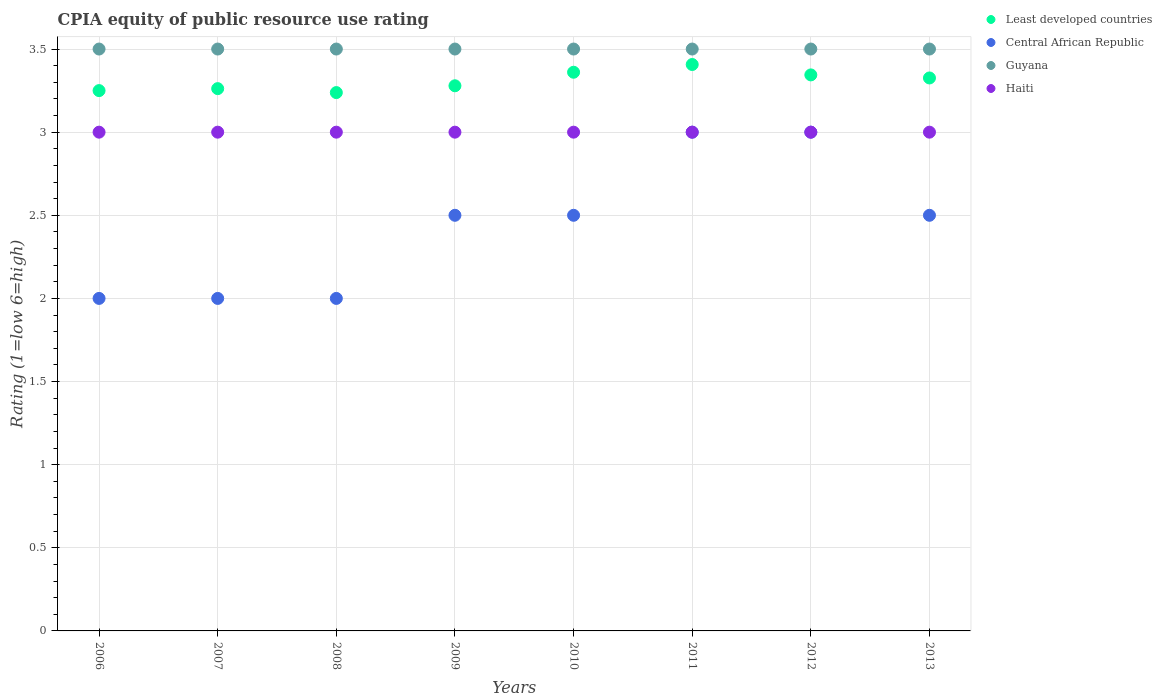Is the number of dotlines equal to the number of legend labels?
Your answer should be compact. Yes. What is the CPIA rating in Least developed countries in 2009?
Ensure brevity in your answer.  3.28. Across all years, what is the maximum CPIA rating in Haiti?
Make the answer very short. 3. In which year was the CPIA rating in Least developed countries maximum?
Offer a very short reply. 2011. What is the total CPIA rating in Haiti in the graph?
Ensure brevity in your answer.  24. What is the difference between the CPIA rating in Central African Republic in 2008 and the CPIA rating in Haiti in 2007?
Your response must be concise. -1. What is the average CPIA rating in Central African Republic per year?
Offer a terse response. 2.44. In the year 2010, what is the difference between the CPIA rating in Least developed countries and CPIA rating in Guyana?
Offer a very short reply. -0.14. In how many years, is the CPIA rating in Least developed countries greater than 0.2?
Offer a very short reply. 8. Is the CPIA rating in Haiti in 2006 less than that in 2013?
Your answer should be compact. No. Is the difference between the CPIA rating in Least developed countries in 2008 and 2012 greater than the difference between the CPIA rating in Guyana in 2008 and 2012?
Offer a terse response. No. What is the difference between the highest and the second highest CPIA rating in Guyana?
Offer a terse response. 0. What is the difference between the highest and the lowest CPIA rating in Least developed countries?
Ensure brevity in your answer.  0.17. Is the sum of the CPIA rating in Least developed countries in 2010 and 2013 greater than the maximum CPIA rating in Haiti across all years?
Your answer should be very brief. Yes. Does the CPIA rating in Central African Republic monotonically increase over the years?
Your answer should be compact. No. Is the CPIA rating in Haiti strictly less than the CPIA rating in Least developed countries over the years?
Offer a terse response. Yes. How many dotlines are there?
Provide a short and direct response. 4. How many years are there in the graph?
Ensure brevity in your answer.  8. Does the graph contain any zero values?
Provide a short and direct response. No. Does the graph contain grids?
Offer a very short reply. Yes. Where does the legend appear in the graph?
Offer a very short reply. Top right. What is the title of the graph?
Offer a very short reply. CPIA equity of public resource use rating. Does "Montenegro" appear as one of the legend labels in the graph?
Keep it short and to the point. No. What is the label or title of the X-axis?
Offer a very short reply. Years. What is the label or title of the Y-axis?
Your response must be concise. Rating (1=low 6=high). What is the Rating (1=low 6=high) in Least developed countries in 2006?
Your answer should be very brief. 3.25. What is the Rating (1=low 6=high) of Haiti in 2006?
Keep it short and to the point. 3. What is the Rating (1=low 6=high) of Least developed countries in 2007?
Your answer should be very brief. 3.26. What is the Rating (1=low 6=high) in Central African Republic in 2007?
Keep it short and to the point. 2. What is the Rating (1=low 6=high) in Guyana in 2007?
Ensure brevity in your answer.  3.5. What is the Rating (1=low 6=high) of Least developed countries in 2008?
Your answer should be very brief. 3.24. What is the Rating (1=low 6=high) of Least developed countries in 2009?
Provide a succinct answer. 3.28. What is the Rating (1=low 6=high) of Central African Republic in 2009?
Give a very brief answer. 2.5. What is the Rating (1=low 6=high) of Least developed countries in 2010?
Make the answer very short. 3.36. What is the Rating (1=low 6=high) in Central African Republic in 2010?
Give a very brief answer. 2.5. What is the Rating (1=low 6=high) in Guyana in 2010?
Provide a short and direct response. 3.5. What is the Rating (1=low 6=high) in Haiti in 2010?
Offer a very short reply. 3. What is the Rating (1=low 6=high) in Least developed countries in 2011?
Make the answer very short. 3.41. What is the Rating (1=low 6=high) in Least developed countries in 2012?
Provide a succinct answer. 3.34. What is the Rating (1=low 6=high) of Central African Republic in 2012?
Give a very brief answer. 3. What is the Rating (1=low 6=high) of Guyana in 2012?
Offer a terse response. 3.5. What is the Rating (1=low 6=high) in Haiti in 2012?
Your answer should be very brief. 3. What is the Rating (1=low 6=high) in Least developed countries in 2013?
Offer a very short reply. 3.33. What is the Rating (1=low 6=high) in Central African Republic in 2013?
Provide a succinct answer. 2.5. What is the Rating (1=low 6=high) in Guyana in 2013?
Offer a terse response. 3.5. Across all years, what is the maximum Rating (1=low 6=high) in Least developed countries?
Your answer should be very brief. 3.41. Across all years, what is the maximum Rating (1=low 6=high) in Central African Republic?
Give a very brief answer. 3. Across all years, what is the maximum Rating (1=low 6=high) in Guyana?
Offer a terse response. 3.5. Across all years, what is the maximum Rating (1=low 6=high) of Haiti?
Provide a succinct answer. 3. Across all years, what is the minimum Rating (1=low 6=high) of Least developed countries?
Make the answer very short. 3.24. Across all years, what is the minimum Rating (1=low 6=high) of Guyana?
Your answer should be compact. 3.5. Across all years, what is the minimum Rating (1=low 6=high) of Haiti?
Make the answer very short. 3. What is the total Rating (1=low 6=high) in Least developed countries in the graph?
Offer a terse response. 26.47. What is the total Rating (1=low 6=high) of Guyana in the graph?
Your response must be concise. 28. What is the difference between the Rating (1=low 6=high) in Least developed countries in 2006 and that in 2007?
Provide a succinct answer. -0.01. What is the difference between the Rating (1=low 6=high) of Guyana in 2006 and that in 2007?
Provide a short and direct response. 0. What is the difference between the Rating (1=low 6=high) of Least developed countries in 2006 and that in 2008?
Ensure brevity in your answer.  0.01. What is the difference between the Rating (1=low 6=high) of Central African Republic in 2006 and that in 2008?
Ensure brevity in your answer.  0. What is the difference between the Rating (1=low 6=high) in Guyana in 2006 and that in 2008?
Your response must be concise. 0. What is the difference between the Rating (1=low 6=high) of Least developed countries in 2006 and that in 2009?
Make the answer very short. -0.03. What is the difference between the Rating (1=low 6=high) in Central African Republic in 2006 and that in 2009?
Provide a succinct answer. -0.5. What is the difference between the Rating (1=low 6=high) in Least developed countries in 2006 and that in 2010?
Keep it short and to the point. -0.11. What is the difference between the Rating (1=low 6=high) of Central African Republic in 2006 and that in 2010?
Keep it short and to the point. -0.5. What is the difference between the Rating (1=low 6=high) in Guyana in 2006 and that in 2010?
Make the answer very short. 0. What is the difference between the Rating (1=low 6=high) in Least developed countries in 2006 and that in 2011?
Your answer should be compact. -0.16. What is the difference between the Rating (1=low 6=high) of Central African Republic in 2006 and that in 2011?
Your answer should be very brief. -1. What is the difference between the Rating (1=low 6=high) of Haiti in 2006 and that in 2011?
Provide a short and direct response. 0. What is the difference between the Rating (1=low 6=high) of Least developed countries in 2006 and that in 2012?
Offer a terse response. -0.09. What is the difference between the Rating (1=low 6=high) in Central African Republic in 2006 and that in 2012?
Your answer should be compact. -1. What is the difference between the Rating (1=low 6=high) of Least developed countries in 2006 and that in 2013?
Give a very brief answer. -0.08. What is the difference between the Rating (1=low 6=high) in Central African Republic in 2006 and that in 2013?
Offer a terse response. -0.5. What is the difference between the Rating (1=low 6=high) of Haiti in 2006 and that in 2013?
Your response must be concise. 0. What is the difference between the Rating (1=low 6=high) in Least developed countries in 2007 and that in 2008?
Your response must be concise. 0.02. What is the difference between the Rating (1=low 6=high) of Central African Republic in 2007 and that in 2008?
Provide a short and direct response. 0. What is the difference between the Rating (1=low 6=high) in Guyana in 2007 and that in 2008?
Provide a succinct answer. 0. What is the difference between the Rating (1=low 6=high) in Haiti in 2007 and that in 2008?
Keep it short and to the point. 0. What is the difference between the Rating (1=low 6=high) of Least developed countries in 2007 and that in 2009?
Offer a very short reply. -0.02. What is the difference between the Rating (1=low 6=high) of Least developed countries in 2007 and that in 2010?
Your answer should be compact. -0.1. What is the difference between the Rating (1=low 6=high) of Least developed countries in 2007 and that in 2011?
Keep it short and to the point. -0.15. What is the difference between the Rating (1=low 6=high) in Central African Republic in 2007 and that in 2011?
Make the answer very short. -1. What is the difference between the Rating (1=low 6=high) in Guyana in 2007 and that in 2011?
Provide a succinct answer. 0. What is the difference between the Rating (1=low 6=high) of Least developed countries in 2007 and that in 2012?
Offer a very short reply. -0.08. What is the difference between the Rating (1=low 6=high) of Central African Republic in 2007 and that in 2012?
Provide a short and direct response. -1. What is the difference between the Rating (1=low 6=high) in Guyana in 2007 and that in 2012?
Give a very brief answer. 0. What is the difference between the Rating (1=low 6=high) of Least developed countries in 2007 and that in 2013?
Your response must be concise. -0.06. What is the difference between the Rating (1=low 6=high) in Central African Republic in 2007 and that in 2013?
Keep it short and to the point. -0.5. What is the difference between the Rating (1=low 6=high) in Guyana in 2007 and that in 2013?
Give a very brief answer. 0. What is the difference between the Rating (1=low 6=high) in Least developed countries in 2008 and that in 2009?
Ensure brevity in your answer.  -0.04. What is the difference between the Rating (1=low 6=high) of Central African Republic in 2008 and that in 2009?
Offer a terse response. -0.5. What is the difference between the Rating (1=low 6=high) of Least developed countries in 2008 and that in 2010?
Ensure brevity in your answer.  -0.12. What is the difference between the Rating (1=low 6=high) of Central African Republic in 2008 and that in 2010?
Your response must be concise. -0.5. What is the difference between the Rating (1=low 6=high) of Guyana in 2008 and that in 2010?
Make the answer very short. 0. What is the difference between the Rating (1=low 6=high) in Haiti in 2008 and that in 2010?
Your answer should be very brief. 0. What is the difference between the Rating (1=low 6=high) in Least developed countries in 2008 and that in 2011?
Keep it short and to the point. -0.17. What is the difference between the Rating (1=low 6=high) of Central African Republic in 2008 and that in 2011?
Provide a succinct answer. -1. What is the difference between the Rating (1=low 6=high) of Haiti in 2008 and that in 2011?
Your answer should be compact. 0. What is the difference between the Rating (1=low 6=high) in Least developed countries in 2008 and that in 2012?
Give a very brief answer. -0.11. What is the difference between the Rating (1=low 6=high) of Guyana in 2008 and that in 2012?
Keep it short and to the point. 0. What is the difference between the Rating (1=low 6=high) of Haiti in 2008 and that in 2012?
Your answer should be compact. 0. What is the difference between the Rating (1=low 6=high) in Least developed countries in 2008 and that in 2013?
Provide a short and direct response. -0.09. What is the difference between the Rating (1=low 6=high) of Central African Republic in 2008 and that in 2013?
Offer a very short reply. -0.5. What is the difference between the Rating (1=low 6=high) in Guyana in 2008 and that in 2013?
Your response must be concise. 0. What is the difference between the Rating (1=low 6=high) in Haiti in 2008 and that in 2013?
Provide a succinct answer. 0. What is the difference between the Rating (1=low 6=high) in Least developed countries in 2009 and that in 2010?
Ensure brevity in your answer.  -0.08. What is the difference between the Rating (1=low 6=high) of Guyana in 2009 and that in 2010?
Your response must be concise. 0. What is the difference between the Rating (1=low 6=high) of Haiti in 2009 and that in 2010?
Give a very brief answer. 0. What is the difference between the Rating (1=low 6=high) in Least developed countries in 2009 and that in 2011?
Give a very brief answer. -0.13. What is the difference between the Rating (1=low 6=high) in Central African Republic in 2009 and that in 2011?
Offer a terse response. -0.5. What is the difference between the Rating (1=low 6=high) in Haiti in 2009 and that in 2011?
Ensure brevity in your answer.  0. What is the difference between the Rating (1=low 6=high) in Least developed countries in 2009 and that in 2012?
Give a very brief answer. -0.07. What is the difference between the Rating (1=low 6=high) in Central African Republic in 2009 and that in 2012?
Keep it short and to the point. -0.5. What is the difference between the Rating (1=low 6=high) in Guyana in 2009 and that in 2012?
Your answer should be very brief. 0. What is the difference between the Rating (1=low 6=high) of Haiti in 2009 and that in 2012?
Offer a terse response. 0. What is the difference between the Rating (1=low 6=high) of Least developed countries in 2009 and that in 2013?
Your response must be concise. -0.05. What is the difference between the Rating (1=low 6=high) of Least developed countries in 2010 and that in 2011?
Provide a short and direct response. -0.05. What is the difference between the Rating (1=low 6=high) of Central African Republic in 2010 and that in 2011?
Your response must be concise. -0.5. What is the difference between the Rating (1=low 6=high) in Least developed countries in 2010 and that in 2012?
Your response must be concise. 0.02. What is the difference between the Rating (1=low 6=high) in Central African Republic in 2010 and that in 2012?
Your answer should be compact. -0.5. What is the difference between the Rating (1=low 6=high) of Haiti in 2010 and that in 2012?
Your answer should be compact. 0. What is the difference between the Rating (1=low 6=high) in Least developed countries in 2010 and that in 2013?
Your answer should be compact. 0.03. What is the difference between the Rating (1=low 6=high) of Central African Republic in 2010 and that in 2013?
Your response must be concise. 0. What is the difference between the Rating (1=low 6=high) of Haiti in 2010 and that in 2013?
Make the answer very short. 0. What is the difference between the Rating (1=low 6=high) in Least developed countries in 2011 and that in 2012?
Provide a succinct answer. 0.06. What is the difference between the Rating (1=low 6=high) in Haiti in 2011 and that in 2012?
Provide a succinct answer. 0. What is the difference between the Rating (1=low 6=high) of Least developed countries in 2011 and that in 2013?
Your response must be concise. 0.08. What is the difference between the Rating (1=low 6=high) of Guyana in 2011 and that in 2013?
Give a very brief answer. 0. What is the difference between the Rating (1=low 6=high) in Least developed countries in 2012 and that in 2013?
Offer a terse response. 0.02. What is the difference between the Rating (1=low 6=high) in Least developed countries in 2006 and the Rating (1=low 6=high) in Central African Republic in 2007?
Make the answer very short. 1.25. What is the difference between the Rating (1=low 6=high) of Least developed countries in 2006 and the Rating (1=low 6=high) of Guyana in 2007?
Ensure brevity in your answer.  -0.25. What is the difference between the Rating (1=low 6=high) of Least developed countries in 2006 and the Rating (1=low 6=high) of Haiti in 2007?
Make the answer very short. 0.25. What is the difference between the Rating (1=low 6=high) in Central African Republic in 2006 and the Rating (1=low 6=high) in Guyana in 2007?
Provide a succinct answer. -1.5. What is the difference between the Rating (1=low 6=high) in Central African Republic in 2006 and the Rating (1=low 6=high) in Haiti in 2007?
Your response must be concise. -1. What is the difference between the Rating (1=low 6=high) in Least developed countries in 2006 and the Rating (1=low 6=high) in Central African Republic in 2008?
Make the answer very short. 1.25. What is the difference between the Rating (1=low 6=high) of Central African Republic in 2006 and the Rating (1=low 6=high) of Guyana in 2008?
Make the answer very short. -1.5. What is the difference between the Rating (1=low 6=high) of Guyana in 2006 and the Rating (1=low 6=high) of Haiti in 2008?
Your answer should be compact. 0.5. What is the difference between the Rating (1=low 6=high) of Least developed countries in 2006 and the Rating (1=low 6=high) of Guyana in 2009?
Your answer should be compact. -0.25. What is the difference between the Rating (1=low 6=high) in Least developed countries in 2006 and the Rating (1=low 6=high) in Haiti in 2009?
Ensure brevity in your answer.  0.25. What is the difference between the Rating (1=low 6=high) of Central African Republic in 2006 and the Rating (1=low 6=high) of Haiti in 2009?
Give a very brief answer. -1. What is the difference between the Rating (1=low 6=high) of Least developed countries in 2006 and the Rating (1=low 6=high) of Central African Republic in 2010?
Provide a short and direct response. 0.75. What is the difference between the Rating (1=low 6=high) of Least developed countries in 2006 and the Rating (1=low 6=high) of Guyana in 2010?
Offer a terse response. -0.25. What is the difference between the Rating (1=low 6=high) of Least developed countries in 2006 and the Rating (1=low 6=high) of Haiti in 2010?
Provide a succinct answer. 0.25. What is the difference between the Rating (1=low 6=high) of Central African Republic in 2006 and the Rating (1=low 6=high) of Guyana in 2010?
Your answer should be very brief. -1.5. What is the difference between the Rating (1=low 6=high) of Guyana in 2006 and the Rating (1=low 6=high) of Haiti in 2010?
Keep it short and to the point. 0.5. What is the difference between the Rating (1=low 6=high) in Least developed countries in 2006 and the Rating (1=low 6=high) in Guyana in 2011?
Give a very brief answer. -0.25. What is the difference between the Rating (1=low 6=high) in Central African Republic in 2006 and the Rating (1=low 6=high) in Haiti in 2011?
Give a very brief answer. -1. What is the difference between the Rating (1=low 6=high) of Least developed countries in 2006 and the Rating (1=low 6=high) of Central African Republic in 2012?
Your answer should be compact. 0.25. What is the difference between the Rating (1=low 6=high) in Central African Republic in 2006 and the Rating (1=low 6=high) in Guyana in 2012?
Provide a short and direct response. -1.5. What is the difference between the Rating (1=low 6=high) in Central African Republic in 2006 and the Rating (1=low 6=high) in Haiti in 2012?
Ensure brevity in your answer.  -1. What is the difference between the Rating (1=low 6=high) in Least developed countries in 2006 and the Rating (1=low 6=high) in Central African Republic in 2013?
Provide a succinct answer. 0.75. What is the difference between the Rating (1=low 6=high) of Least developed countries in 2006 and the Rating (1=low 6=high) of Guyana in 2013?
Offer a very short reply. -0.25. What is the difference between the Rating (1=low 6=high) of Least developed countries in 2006 and the Rating (1=low 6=high) of Haiti in 2013?
Make the answer very short. 0.25. What is the difference between the Rating (1=low 6=high) of Least developed countries in 2007 and the Rating (1=low 6=high) of Central African Republic in 2008?
Provide a succinct answer. 1.26. What is the difference between the Rating (1=low 6=high) of Least developed countries in 2007 and the Rating (1=low 6=high) of Guyana in 2008?
Your response must be concise. -0.24. What is the difference between the Rating (1=low 6=high) in Least developed countries in 2007 and the Rating (1=low 6=high) in Haiti in 2008?
Ensure brevity in your answer.  0.26. What is the difference between the Rating (1=low 6=high) of Central African Republic in 2007 and the Rating (1=low 6=high) of Haiti in 2008?
Your answer should be compact. -1. What is the difference between the Rating (1=low 6=high) in Least developed countries in 2007 and the Rating (1=low 6=high) in Central African Republic in 2009?
Your response must be concise. 0.76. What is the difference between the Rating (1=low 6=high) in Least developed countries in 2007 and the Rating (1=low 6=high) in Guyana in 2009?
Ensure brevity in your answer.  -0.24. What is the difference between the Rating (1=low 6=high) of Least developed countries in 2007 and the Rating (1=low 6=high) of Haiti in 2009?
Offer a very short reply. 0.26. What is the difference between the Rating (1=low 6=high) of Guyana in 2007 and the Rating (1=low 6=high) of Haiti in 2009?
Ensure brevity in your answer.  0.5. What is the difference between the Rating (1=low 6=high) of Least developed countries in 2007 and the Rating (1=low 6=high) of Central African Republic in 2010?
Your response must be concise. 0.76. What is the difference between the Rating (1=low 6=high) of Least developed countries in 2007 and the Rating (1=low 6=high) of Guyana in 2010?
Your answer should be very brief. -0.24. What is the difference between the Rating (1=low 6=high) of Least developed countries in 2007 and the Rating (1=low 6=high) of Haiti in 2010?
Your answer should be compact. 0.26. What is the difference between the Rating (1=low 6=high) of Central African Republic in 2007 and the Rating (1=low 6=high) of Guyana in 2010?
Offer a terse response. -1.5. What is the difference between the Rating (1=low 6=high) of Guyana in 2007 and the Rating (1=low 6=high) of Haiti in 2010?
Provide a succinct answer. 0.5. What is the difference between the Rating (1=low 6=high) of Least developed countries in 2007 and the Rating (1=low 6=high) of Central African Republic in 2011?
Keep it short and to the point. 0.26. What is the difference between the Rating (1=low 6=high) of Least developed countries in 2007 and the Rating (1=low 6=high) of Guyana in 2011?
Ensure brevity in your answer.  -0.24. What is the difference between the Rating (1=low 6=high) in Least developed countries in 2007 and the Rating (1=low 6=high) in Haiti in 2011?
Make the answer very short. 0.26. What is the difference between the Rating (1=low 6=high) in Central African Republic in 2007 and the Rating (1=low 6=high) in Guyana in 2011?
Your answer should be very brief. -1.5. What is the difference between the Rating (1=low 6=high) of Guyana in 2007 and the Rating (1=low 6=high) of Haiti in 2011?
Your answer should be compact. 0.5. What is the difference between the Rating (1=low 6=high) in Least developed countries in 2007 and the Rating (1=low 6=high) in Central African Republic in 2012?
Offer a terse response. 0.26. What is the difference between the Rating (1=low 6=high) in Least developed countries in 2007 and the Rating (1=low 6=high) in Guyana in 2012?
Provide a succinct answer. -0.24. What is the difference between the Rating (1=low 6=high) of Least developed countries in 2007 and the Rating (1=low 6=high) of Haiti in 2012?
Give a very brief answer. 0.26. What is the difference between the Rating (1=low 6=high) in Central African Republic in 2007 and the Rating (1=low 6=high) in Guyana in 2012?
Provide a succinct answer. -1.5. What is the difference between the Rating (1=low 6=high) of Central African Republic in 2007 and the Rating (1=low 6=high) of Haiti in 2012?
Keep it short and to the point. -1. What is the difference between the Rating (1=low 6=high) of Least developed countries in 2007 and the Rating (1=low 6=high) of Central African Republic in 2013?
Ensure brevity in your answer.  0.76. What is the difference between the Rating (1=low 6=high) of Least developed countries in 2007 and the Rating (1=low 6=high) of Guyana in 2013?
Provide a short and direct response. -0.24. What is the difference between the Rating (1=low 6=high) of Least developed countries in 2007 and the Rating (1=low 6=high) of Haiti in 2013?
Your answer should be very brief. 0.26. What is the difference between the Rating (1=low 6=high) in Central African Republic in 2007 and the Rating (1=low 6=high) in Guyana in 2013?
Your response must be concise. -1.5. What is the difference between the Rating (1=low 6=high) in Guyana in 2007 and the Rating (1=low 6=high) in Haiti in 2013?
Your answer should be compact. 0.5. What is the difference between the Rating (1=low 6=high) in Least developed countries in 2008 and the Rating (1=low 6=high) in Central African Republic in 2009?
Your response must be concise. 0.74. What is the difference between the Rating (1=low 6=high) of Least developed countries in 2008 and the Rating (1=low 6=high) of Guyana in 2009?
Your response must be concise. -0.26. What is the difference between the Rating (1=low 6=high) of Least developed countries in 2008 and the Rating (1=low 6=high) of Haiti in 2009?
Ensure brevity in your answer.  0.24. What is the difference between the Rating (1=low 6=high) of Central African Republic in 2008 and the Rating (1=low 6=high) of Guyana in 2009?
Your answer should be compact. -1.5. What is the difference between the Rating (1=low 6=high) of Least developed countries in 2008 and the Rating (1=low 6=high) of Central African Republic in 2010?
Ensure brevity in your answer.  0.74. What is the difference between the Rating (1=low 6=high) of Least developed countries in 2008 and the Rating (1=low 6=high) of Guyana in 2010?
Your answer should be compact. -0.26. What is the difference between the Rating (1=low 6=high) in Least developed countries in 2008 and the Rating (1=low 6=high) in Haiti in 2010?
Provide a short and direct response. 0.24. What is the difference between the Rating (1=low 6=high) in Central African Republic in 2008 and the Rating (1=low 6=high) in Guyana in 2010?
Keep it short and to the point. -1.5. What is the difference between the Rating (1=low 6=high) in Central African Republic in 2008 and the Rating (1=low 6=high) in Haiti in 2010?
Provide a succinct answer. -1. What is the difference between the Rating (1=low 6=high) of Least developed countries in 2008 and the Rating (1=low 6=high) of Central African Republic in 2011?
Give a very brief answer. 0.24. What is the difference between the Rating (1=low 6=high) of Least developed countries in 2008 and the Rating (1=low 6=high) of Guyana in 2011?
Offer a terse response. -0.26. What is the difference between the Rating (1=low 6=high) in Least developed countries in 2008 and the Rating (1=low 6=high) in Haiti in 2011?
Provide a succinct answer. 0.24. What is the difference between the Rating (1=low 6=high) in Central African Republic in 2008 and the Rating (1=low 6=high) in Haiti in 2011?
Offer a terse response. -1. What is the difference between the Rating (1=low 6=high) in Least developed countries in 2008 and the Rating (1=low 6=high) in Central African Republic in 2012?
Offer a very short reply. 0.24. What is the difference between the Rating (1=low 6=high) of Least developed countries in 2008 and the Rating (1=low 6=high) of Guyana in 2012?
Provide a short and direct response. -0.26. What is the difference between the Rating (1=low 6=high) of Least developed countries in 2008 and the Rating (1=low 6=high) of Haiti in 2012?
Your answer should be very brief. 0.24. What is the difference between the Rating (1=low 6=high) in Central African Republic in 2008 and the Rating (1=low 6=high) in Guyana in 2012?
Ensure brevity in your answer.  -1.5. What is the difference between the Rating (1=low 6=high) in Guyana in 2008 and the Rating (1=low 6=high) in Haiti in 2012?
Give a very brief answer. 0.5. What is the difference between the Rating (1=low 6=high) in Least developed countries in 2008 and the Rating (1=low 6=high) in Central African Republic in 2013?
Give a very brief answer. 0.74. What is the difference between the Rating (1=low 6=high) in Least developed countries in 2008 and the Rating (1=low 6=high) in Guyana in 2013?
Offer a terse response. -0.26. What is the difference between the Rating (1=low 6=high) in Least developed countries in 2008 and the Rating (1=low 6=high) in Haiti in 2013?
Your answer should be compact. 0.24. What is the difference between the Rating (1=low 6=high) of Central African Republic in 2008 and the Rating (1=low 6=high) of Guyana in 2013?
Ensure brevity in your answer.  -1.5. What is the difference between the Rating (1=low 6=high) in Least developed countries in 2009 and the Rating (1=low 6=high) in Central African Republic in 2010?
Ensure brevity in your answer.  0.78. What is the difference between the Rating (1=low 6=high) in Least developed countries in 2009 and the Rating (1=low 6=high) in Guyana in 2010?
Your answer should be very brief. -0.22. What is the difference between the Rating (1=low 6=high) of Least developed countries in 2009 and the Rating (1=low 6=high) of Haiti in 2010?
Keep it short and to the point. 0.28. What is the difference between the Rating (1=low 6=high) of Central African Republic in 2009 and the Rating (1=low 6=high) of Guyana in 2010?
Make the answer very short. -1. What is the difference between the Rating (1=low 6=high) in Central African Republic in 2009 and the Rating (1=low 6=high) in Haiti in 2010?
Keep it short and to the point. -0.5. What is the difference between the Rating (1=low 6=high) of Least developed countries in 2009 and the Rating (1=low 6=high) of Central African Republic in 2011?
Keep it short and to the point. 0.28. What is the difference between the Rating (1=low 6=high) of Least developed countries in 2009 and the Rating (1=low 6=high) of Guyana in 2011?
Your answer should be compact. -0.22. What is the difference between the Rating (1=low 6=high) in Least developed countries in 2009 and the Rating (1=low 6=high) in Haiti in 2011?
Give a very brief answer. 0.28. What is the difference between the Rating (1=low 6=high) in Central African Republic in 2009 and the Rating (1=low 6=high) in Guyana in 2011?
Offer a very short reply. -1. What is the difference between the Rating (1=low 6=high) of Central African Republic in 2009 and the Rating (1=low 6=high) of Haiti in 2011?
Your answer should be compact. -0.5. What is the difference between the Rating (1=low 6=high) of Guyana in 2009 and the Rating (1=low 6=high) of Haiti in 2011?
Offer a very short reply. 0.5. What is the difference between the Rating (1=low 6=high) in Least developed countries in 2009 and the Rating (1=low 6=high) in Central African Republic in 2012?
Make the answer very short. 0.28. What is the difference between the Rating (1=low 6=high) in Least developed countries in 2009 and the Rating (1=low 6=high) in Guyana in 2012?
Offer a very short reply. -0.22. What is the difference between the Rating (1=low 6=high) in Least developed countries in 2009 and the Rating (1=low 6=high) in Haiti in 2012?
Your answer should be very brief. 0.28. What is the difference between the Rating (1=low 6=high) in Central African Republic in 2009 and the Rating (1=low 6=high) in Haiti in 2012?
Ensure brevity in your answer.  -0.5. What is the difference between the Rating (1=low 6=high) in Least developed countries in 2009 and the Rating (1=low 6=high) in Central African Republic in 2013?
Give a very brief answer. 0.78. What is the difference between the Rating (1=low 6=high) in Least developed countries in 2009 and the Rating (1=low 6=high) in Guyana in 2013?
Your response must be concise. -0.22. What is the difference between the Rating (1=low 6=high) of Least developed countries in 2009 and the Rating (1=low 6=high) of Haiti in 2013?
Offer a very short reply. 0.28. What is the difference between the Rating (1=low 6=high) of Guyana in 2009 and the Rating (1=low 6=high) of Haiti in 2013?
Your answer should be very brief. 0.5. What is the difference between the Rating (1=low 6=high) in Least developed countries in 2010 and the Rating (1=low 6=high) in Central African Republic in 2011?
Give a very brief answer. 0.36. What is the difference between the Rating (1=low 6=high) of Least developed countries in 2010 and the Rating (1=low 6=high) of Guyana in 2011?
Ensure brevity in your answer.  -0.14. What is the difference between the Rating (1=low 6=high) in Least developed countries in 2010 and the Rating (1=low 6=high) in Haiti in 2011?
Offer a terse response. 0.36. What is the difference between the Rating (1=low 6=high) of Central African Republic in 2010 and the Rating (1=low 6=high) of Haiti in 2011?
Offer a terse response. -0.5. What is the difference between the Rating (1=low 6=high) in Guyana in 2010 and the Rating (1=low 6=high) in Haiti in 2011?
Keep it short and to the point. 0.5. What is the difference between the Rating (1=low 6=high) of Least developed countries in 2010 and the Rating (1=low 6=high) of Central African Republic in 2012?
Provide a succinct answer. 0.36. What is the difference between the Rating (1=low 6=high) in Least developed countries in 2010 and the Rating (1=low 6=high) in Guyana in 2012?
Your answer should be compact. -0.14. What is the difference between the Rating (1=low 6=high) in Least developed countries in 2010 and the Rating (1=low 6=high) in Haiti in 2012?
Your answer should be compact. 0.36. What is the difference between the Rating (1=low 6=high) in Central African Republic in 2010 and the Rating (1=low 6=high) in Guyana in 2012?
Your response must be concise. -1. What is the difference between the Rating (1=low 6=high) in Central African Republic in 2010 and the Rating (1=low 6=high) in Haiti in 2012?
Provide a succinct answer. -0.5. What is the difference between the Rating (1=low 6=high) in Guyana in 2010 and the Rating (1=low 6=high) in Haiti in 2012?
Your answer should be compact. 0.5. What is the difference between the Rating (1=low 6=high) in Least developed countries in 2010 and the Rating (1=low 6=high) in Central African Republic in 2013?
Keep it short and to the point. 0.86. What is the difference between the Rating (1=low 6=high) of Least developed countries in 2010 and the Rating (1=low 6=high) of Guyana in 2013?
Your answer should be compact. -0.14. What is the difference between the Rating (1=low 6=high) in Least developed countries in 2010 and the Rating (1=low 6=high) in Haiti in 2013?
Give a very brief answer. 0.36. What is the difference between the Rating (1=low 6=high) in Central African Republic in 2010 and the Rating (1=low 6=high) in Guyana in 2013?
Provide a succinct answer. -1. What is the difference between the Rating (1=low 6=high) of Least developed countries in 2011 and the Rating (1=low 6=high) of Central African Republic in 2012?
Keep it short and to the point. 0.41. What is the difference between the Rating (1=low 6=high) of Least developed countries in 2011 and the Rating (1=low 6=high) of Guyana in 2012?
Give a very brief answer. -0.09. What is the difference between the Rating (1=low 6=high) in Least developed countries in 2011 and the Rating (1=low 6=high) in Haiti in 2012?
Provide a short and direct response. 0.41. What is the difference between the Rating (1=low 6=high) of Central African Republic in 2011 and the Rating (1=low 6=high) of Haiti in 2012?
Provide a succinct answer. 0. What is the difference between the Rating (1=low 6=high) of Least developed countries in 2011 and the Rating (1=low 6=high) of Central African Republic in 2013?
Offer a terse response. 0.91. What is the difference between the Rating (1=low 6=high) in Least developed countries in 2011 and the Rating (1=low 6=high) in Guyana in 2013?
Provide a short and direct response. -0.09. What is the difference between the Rating (1=low 6=high) in Least developed countries in 2011 and the Rating (1=low 6=high) in Haiti in 2013?
Your answer should be compact. 0.41. What is the difference between the Rating (1=low 6=high) in Least developed countries in 2012 and the Rating (1=low 6=high) in Central African Republic in 2013?
Provide a succinct answer. 0.84. What is the difference between the Rating (1=low 6=high) in Least developed countries in 2012 and the Rating (1=low 6=high) in Guyana in 2013?
Give a very brief answer. -0.16. What is the difference between the Rating (1=low 6=high) in Least developed countries in 2012 and the Rating (1=low 6=high) in Haiti in 2013?
Ensure brevity in your answer.  0.34. What is the difference between the Rating (1=low 6=high) in Central African Republic in 2012 and the Rating (1=low 6=high) in Guyana in 2013?
Your answer should be compact. -0.5. What is the average Rating (1=low 6=high) in Least developed countries per year?
Offer a terse response. 3.31. What is the average Rating (1=low 6=high) of Central African Republic per year?
Your answer should be compact. 2.44. What is the average Rating (1=low 6=high) of Guyana per year?
Offer a terse response. 3.5. In the year 2006, what is the difference between the Rating (1=low 6=high) of Least developed countries and Rating (1=low 6=high) of Central African Republic?
Provide a succinct answer. 1.25. In the year 2006, what is the difference between the Rating (1=low 6=high) of Least developed countries and Rating (1=low 6=high) of Haiti?
Your answer should be compact. 0.25. In the year 2006, what is the difference between the Rating (1=low 6=high) of Central African Republic and Rating (1=low 6=high) of Guyana?
Your answer should be compact. -1.5. In the year 2006, what is the difference between the Rating (1=low 6=high) in Central African Republic and Rating (1=low 6=high) in Haiti?
Make the answer very short. -1. In the year 2007, what is the difference between the Rating (1=low 6=high) of Least developed countries and Rating (1=low 6=high) of Central African Republic?
Ensure brevity in your answer.  1.26. In the year 2007, what is the difference between the Rating (1=low 6=high) in Least developed countries and Rating (1=low 6=high) in Guyana?
Provide a short and direct response. -0.24. In the year 2007, what is the difference between the Rating (1=low 6=high) in Least developed countries and Rating (1=low 6=high) in Haiti?
Provide a short and direct response. 0.26. In the year 2007, what is the difference between the Rating (1=low 6=high) of Central African Republic and Rating (1=low 6=high) of Haiti?
Provide a short and direct response. -1. In the year 2007, what is the difference between the Rating (1=low 6=high) in Guyana and Rating (1=low 6=high) in Haiti?
Provide a succinct answer. 0.5. In the year 2008, what is the difference between the Rating (1=low 6=high) in Least developed countries and Rating (1=low 6=high) in Central African Republic?
Provide a succinct answer. 1.24. In the year 2008, what is the difference between the Rating (1=low 6=high) of Least developed countries and Rating (1=low 6=high) of Guyana?
Offer a terse response. -0.26. In the year 2008, what is the difference between the Rating (1=low 6=high) in Least developed countries and Rating (1=low 6=high) in Haiti?
Offer a terse response. 0.24. In the year 2008, what is the difference between the Rating (1=low 6=high) of Central African Republic and Rating (1=low 6=high) of Guyana?
Your answer should be very brief. -1.5. In the year 2008, what is the difference between the Rating (1=low 6=high) in Guyana and Rating (1=low 6=high) in Haiti?
Provide a short and direct response. 0.5. In the year 2009, what is the difference between the Rating (1=low 6=high) of Least developed countries and Rating (1=low 6=high) of Central African Republic?
Provide a short and direct response. 0.78. In the year 2009, what is the difference between the Rating (1=low 6=high) of Least developed countries and Rating (1=low 6=high) of Guyana?
Offer a terse response. -0.22. In the year 2009, what is the difference between the Rating (1=low 6=high) of Least developed countries and Rating (1=low 6=high) of Haiti?
Make the answer very short. 0.28. In the year 2009, what is the difference between the Rating (1=low 6=high) of Central African Republic and Rating (1=low 6=high) of Guyana?
Offer a terse response. -1. In the year 2009, what is the difference between the Rating (1=low 6=high) in Guyana and Rating (1=low 6=high) in Haiti?
Your answer should be compact. 0.5. In the year 2010, what is the difference between the Rating (1=low 6=high) of Least developed countries and Rating (1=low 6=high) of Central African Republic?
Ensure brevity in your answer.  0.86. In the year 2010, what is the difference between the Rating (1=low 6=high) of Least developed countries and Rating (1=low 6=high) of Guyana?
Ensure brevity in your answer.  -0.14. In the year 2010, what is the difference between the Rating (1=low 6=high) in Least developed countries and Rating (1=low 6=high) in Haiti?
Offer a terse response. 0.36. In the year 2010, what is the difference between the Rating (1=low 6=high) in Central African Republic and Rating (1=low 6=high) in Guyana?
Give a very brief answer. -1. In the year 2010, what is the difference between the Rating (1=low 6=high) of Guyana and Rating (1=low 6=high) of Haiti?
Make the answer very short. 0.5. In the year 2011, what is the difference between the Rating (1=low 6=high) in Least developed countries and Rating (1=low 6=high) in Central African Republic?
Offer a very short reply. 0.41. In the year 2011, what is the difference between the Rating (1=low 6=high) in Least developed countries and Rating (1=low 6=high) in Guyana?
Ensure brevity in your answer.  -0.09. In the year 2011, what is the difference between the Rating (1=low 6=high) in Least developed countries and Rating (1=low 6=high) in Haiti?
Offer a very short reply. 0.41. In the year 2011, what is the difference between the Rating (1=low 6=high) of Guyana and Rating (1=low 6=high) of Haiti?
Your answer should be very brief. 0.5. In the year 2012, what is the difference between the Rating (1=low 6=high) in Least developed countries and Rating (1=low 6=high) in Central African Republic?
Make the answer very short. 0.34. In the year 2012, what is the difference between the Rating (1=low 6=high) of Least developed countries and Rating (1=low 6=high) of Guyana?
Your response must be concise. -0.16. In the year 2012, what is the difference between the Rating (1=low 6=high) in Least developed countries and Rating (1=low 6=high) in Haiti?
Keep it short and to the point. 0.34. In the year 2013, what is the difference between the Rating (1=low 6=high) of Least developed countries and Rating (1=low 6=high) of Central African Republic?
Make the answer very short. 0.83. In the year 2013, what is the difference between the Rating (1=low 6=high) in Least developed countries and Rating (1=low 6=high) in Guyana?
Your answer should be compact. -0.17. In the year 2013, what is the difference between the Rating (1=low 6=high) of Least developed countries and Rating (1=low 6=high) of Haiti?
Your answer should be compact. 0.33. In the year 2013, what is the difference between the Rating (1=low 6=high) in Central African Republic and Rating (1=low 6=high) in Haiti?
Make the answer very short. -0.5. What is the ratio of the Rating (1=low 6=high) of Least developed countries in 2006 to that in 2007?
Provide a succinct answer. 1. What is the ratio of the Rating (1=low 6=high) in Guyana in 2006 to that in 2007?
Offer a very short reply. 1. What is the ratio of the Rating (1=low 6=high) in Guyana in 2006 to that in 2008?
Keep it short and to the point. 1. What is the ratio of the Rating (1=low 6=high) in Haiti in 2006 to that in 2008?
Your answer should be compact. 1. What is the ratio of the Rating (1=low 6=high) in Least developed countries in 2006 to that in 2009?
Your response must be concise. 0.99. What is the ratio of the Rating (1=low 6=high) in Haiti in 2006 to that in 2009?
Give a very brief answer. 1. What is the ratio of the Rating (1=low 6=high) of Least developed countries in 2006 to that in 2010?
Make the answer very short. 0.97. What is the ratio of the Rating (1=low 6=high) of Central African Republic in 2006 to that in 2010?
Offer a very short reply. 0.8. What is the ratio of the Rating (1=low 6=high) in Guyana in 2006 to that in 2010?
Offer a very short reply. 1. What is the ratio of the Rating (1=low 6=high) in Least developed countries in 2006 to that in 2011?
Give a very brief answer. 0.95. What is the ratio of the Rating (1=low 6=high) of Haiti in 2006 to that in 2011?
Provide a short and direct response. 1. What is the ratio of the Rating (1=low 6=high) of Least developed countries in 2006 to that in 2012?
Your answer should be compact. 0.97. What is the ratio of the Rating (1=low 6=high) in Central African Republic in 2006 to that in 2012?
Your response must be concise. 0.67. What is the ratio of the Rating (1=low 6=high) of Haiti in 2006 to that in 2012?
Offer a very short reply. 1. What is the ratio of the Rating (1=low 6=high) in Least developed countries in 2006 to that in 2013?
Your answer should be compact. 0.98. What is the ratio of the Rating (1=low 6=high) of Guyana in 2006 to that in 2013?
Provide a succinct answer. 1. What is the ratio of the Rating (1=low 6=high) of Least developed countries in 2007 to that in 2008?
Offer a terse response. 1.01. What is the ratio of the Rating (1=low 6=high) of Guyana in 2007 to that in 2008?
Provide a short and direct response. 1. What is the ratio of the Rating (1=low 6=high) of Haiti in 2007 to that in 2008?
Offer a very short reply. 1. What is the ratio of the Rating (1=low 6=high) in Central African Republic in 2007 to that in 2009?
Provide a succinct answer. 0.8. What is the ratio of the Rating (1=low 6=high) of Haiti in 2007 to that in 2009?
Your answer should be compact. 1. What is the ratio of the Rating (1=low 6=high) of Least developed countries in 2007 to that in 2010?
Offer a terse response. 0.97. What is the ratio of the Rating (1=low 6=high) of Central African Republic in 2007 to that in 2010?
Offer a very short reply. 0.8. What is the ratio of the Rating (1=low 6=high) in Least developed countries in 2007 to that in 2011?
Offer a terse response. 0.96. What is the ratio of the Rating (1=low 6=high) of Guyana in 2007 to that in 2011?
Your answer should be compact. 1. What is the ratio of the Rating (1=low 6=high) of Least developed countries in 2007 to that in 2012?
Your answer should be very brief. 0.98. What is the ratio of the Rating (1=low 6=high) of Central African Republic in 2007 to that in 2012?
Offer a very short reply. 0.67. What is the ratio of the Rating (1=low 6=high) in Least developed countries in 2007 to that in 2013?
Give a very brief answer. 0.98. What is the ratio of the Rating (1=low 6=high) of Haiti in 2007 to that in 2013?
Your response must be concise. 1. What is the ratio of the Rating (1=low 6=high) in Least developed countries in 2008 to that in 2009?
Provide a short and direct response. 0.99. What is the ratio of the Rating (1=low 6=high) of Guyana in 2008 to that in 2009?
Make the answer very short. 1. What is the ratio of the Rating (1=low 6=high) of Least developed countries in 2008 to that in 2010?
Your response must be concise. 0.96. What is the ratio of the Rating (1=low 6=high) in Least developed countries in 2008 to that in 2011?
Provide a short and direct response. 0.95. What is the ratio of the Rating (1=low 6=high) in Central African Republic in 2008 to that in 2011?
Give a very brief answer. 0.67. What is the ratio of the Rating (1=low 6=high) in Guyana in 2008 to that in 2011?
Give a very brief answer. 1. What is the ratio of the Rating (1=low 6=high) of Haiti in 2008 to that in 2011?
Your answer should be very brief. 1. What is the ratio of the Rating (1=low 6=high) of Least developed countries in 2008 to that in 2012?
Ensure brevity in your answer.  0.97. What is the ratio of the Rating (1=low 6=high) of Central African Republic in 2008 to that in 2012?
Provide a short and direct response. 0.67. What is the ratio of the Rating (1=low 6=high) in Haiti in 2008 to that in 2012?
Offer a terse response. 1. What is the ratio of the Rating (1=low 6=high) in Least developed countries in 2008 to that in 2013?
Your response must be concise. 0.97. What is the ratio of the Rating (1=low 6=high) of Central African Republic in 2008 to that in 2013?
Keep it short and to the point. 0.8. What is the ratio of the Rating (1=low 6=high) of Guyana in 2008 to that in 2013?
Your answer should be compact. 1. What is the ratio of the Rating (1=low 6=high) in Haiti in 2008 to that in 2013?
Your answer should be compact. 1. What is the ratio of the Rating (1=low 6=high) in Least developed countries in 2009 to that in 2010?
Make the answer very short. 0.98. What is the ratio of the Rating (1=low 6=high) in Central African Republic in 2009 to that in 2010?
Provide a succinct answer. 1. What is the ratio of the Rating (1=low 6=high) in Guyana in 2009 to that in 2010?
Keep it short and to the point. 1. What is the ratio of the Rating (1=low 6=high) in Haiti in 2009 to that in 2010?
Your response must be concise. 1. What is the ratio of the Rating (1=low 6=high) of Least developed countries in 2009 to that in 2011?
Offer a very short reply. 0.96. What is the ratio of the Rating (1=low 6=high) of Haiti in 2009 to that in 2011?
Provide a short and direct response. 1. What is the ratio of the Rating (1=low 6=high) in Least developed countries in 2009 to that in 2012?
Your response must be concise. 0.98. What is the ratio of the Rating (1=low 6=high) in Guyana in 2009 to that in 2012?
Offer a terse response. 1. What is the ratio of the Rating (1=low 6=high) of Least developed countries in 2009 to that in 2013?
Offer a terse response. 0.99. What is the ratio of the Rating (1=low 6=high) of Central African Republic in 2009 to that in 2013?
Keep it short and to the point. 1. What is the ratio of the Rating (1=low 6=high) in Guyana in 2009 to that in 2013?
Make the answer very short. 1. What is the ratio of the Rating (1=low 6=high) in Haiti in 2009 to that in 2013?
Offer a terse response. 1. What is the ratio of the Rating (1=low 6=high) of Least developed countries in 2010 to that in 2011?
Your answer should be very brief. 0.99. What is the ratio of the Rating (1=low 6=high) of Guyana in 2010 to that in 2011?
Your response must be concise. 1. What is the ratio of the Rating (1=low 6=high) of Haiti in 2010 to that in 2011?
Ensure brevity in your answer.  1. What is the ratio of the Rating (1=low 6=high) in Central African Republic in 2010 to that in 2012?
Keep it short and to the point. 0.83. What is the ratio of the Rating (1=low 6=high) of Guyana in 2010 to that in 2012?
Ensure brevity in your answer.  1. What is the ratio of the Rating (1=low 6=high) of Haiti in 2010 to that in 2012?
Your answer should be compact. 1. What is the ratio of the Rating (1=low 6=high) of Least developed countries in 2010 to that in 2013?
Your answer should be very brief. 1.01. What is the ratio of the Rating (1=low 6=high) of Central African Republic in 2010 to that in 2013?
Make the answer very short. 1. What is the ratio of the Rating (1=low 6=high) of Guyana in 2010 to that in 2013?
Your answer should be compact. 1. What is the ratio of the Rating (1=low 6=high) of Least developed countries in 2011 to that in 2012?
Provide a short and direct response. 1.02. What is the ratio of the Rating (1=low 6=high) in Central African Republic in 2011 to that in 2012?
Your answer should be very brief. 1. What is the ratio of the Rating (1=low 6=high) in Guyana in 2011 to that in 2012?
Ensure brevity in your answer.  1. What is the ratio of the Rating (1=low 6=high) in Least developed countries in 2011 to that in 2013?
Make the answer very short. 1.02. What is the ratio of the Rating (1=low 6=high) in Haiti in 2011 to that in 2013?
Provide a succinct answer. 1. What is the ratio of the Rating (1=low 6=high) of Least developed countries in 2012 to that in 2013?
Your response must be concise. 1.01. What is the ratio of the Rating (1=low 6=high) of Central African Republic in 2012 to that in 2013?
Give a very brief answer. 1.2. What is the ratio of the Rating (1=low 6=high) in Haiti in 2012 to that in 2013?
Offer a very short reply. 1. What is the difference between the highest and the second highest Rating (1=low 6=high) in Least developed countries?
Your answer should be very brief. 0.05. What is the difference between the highest and the second highest Rating (1=low 6=high) in Central African Republic?
Provide a short and direct response. 0. What is the difference between the highest and the second highest Rating (1=low 6=high) in Guyana?
Your response must be concise. 0. What is the difference between the highest and the second highest Rating (1=low 6=high) in Haiti?
Offer a terse response. 0. What is the difference between the highest and the lowest Rating (1=low 6=high) of Least developed countries?
Give a very brief answer. 0.17. What is the difference between the highest and the lowest Rating (1=low 6=high) of Central African Republic?
Provide a short and direct response. 1. What is the difference between the highest and the lowest Rating (1=low 6=high) in Haiti?
Offer a terse response. 0. 